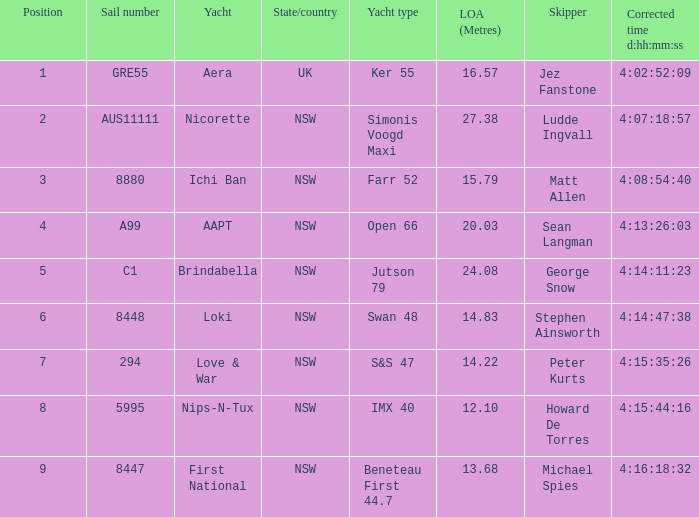Parse the full table. {'header': ['Position', 'Sail number', 'Yacht', 'State/country', 'Yacht type', 'LOA (Metres)', 'Skipper', 'Corrected time d:hh:mm:ss'], 'rows': [['1', 'GRE55', 'Aera', 'UK', 'Ker 55', '16.57', 'Jez Fanstone', '4:02:52:09'], ['2', 'AUS11111', 'Nicorette', 'NSW', 'Simonis Voogd Maxi', '27.38', 'Ludde Ingvall', '4:07:18:57'], ['3', '8880', 'Ichi Ban', 'NSW', 'Farr 52', '15.79', 'Matt Allen', '4:08:54:40'], ['4', 'A99', 'AAPT', 'NSW', 'Open 66', '20.03', 'Sean Langman', '4:13:26:03'], ['5', 'C1', 'Brindabella', 'NSW', 'Jutson 79', '24.08', 'George Snow', '4:14:11:23'], ['6', '8448', 'Loki', 'NSW', 'Swan 48', '14.83', 'Stephen Ainsworth', '4:14:47:38'], ['7', '294', 'Love & War', 'NSW', 'S&S 47', '14.22', 'Peter Kurts', '4:15:35:26'], ['8', '5995', 'Nips-N-Tux', 'NSW', 'IMX 40', '12.10', 'Howard De Torres', '4:15:44:16'], ['9', '8447', 'First National', 'NSW', 'Beneteau First 44.7', '13.68', 'Michael Spies', '4:16:18:32']]} What is the standing for nsw open 66 racing boat? 4.0. 